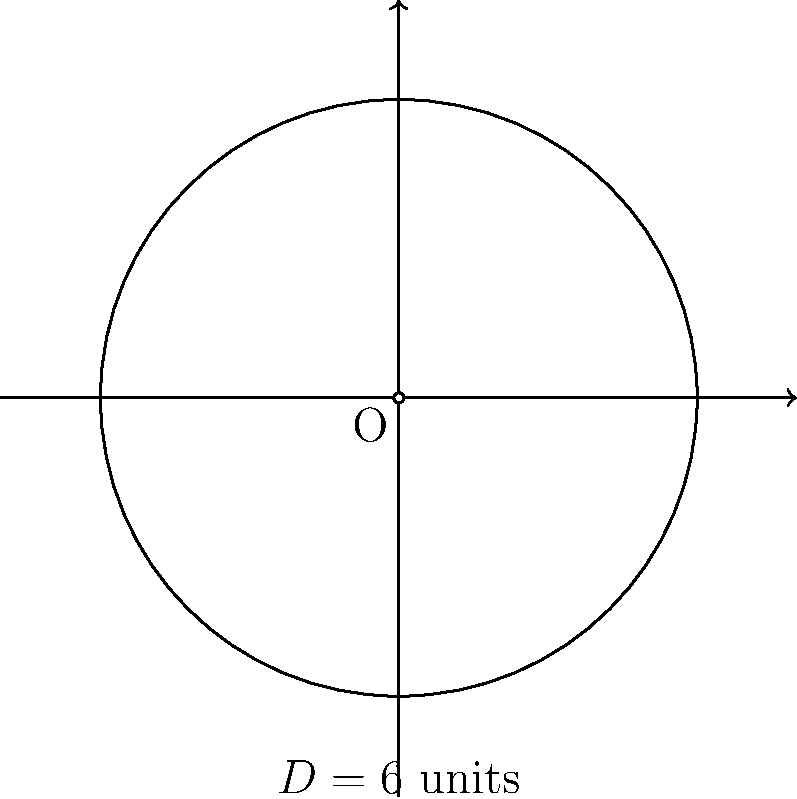In your latest Bob's Burgers fanfiction, Tina decides to build a circular corral for her imaginary horses. If the diameter of the corral is 6 units, calculate its circumference. Use $\pi = 3.14$ for your calculations. To find the circumference of Tina's imaginary horse corral, we'll follow these steps:

1. Recall the formula for the circumference of a circle:
   $C = \pi d$, where $C$ is the circumference, $\pi$ is pi, and $d$ is the diameter.

2. We're given the diameter $d = 6$ units and told to use $\pi = 3.14$.

3. Substitute these values into the formula:
   $C = \pi d$
   $C = 3.14 \times 6$

4. Perform the multiplication:
   $C = 18.84$ units

Therefore, the circumference of Tina's imaginary horse corral is 18.84 units.
Answer: 18.84 units 